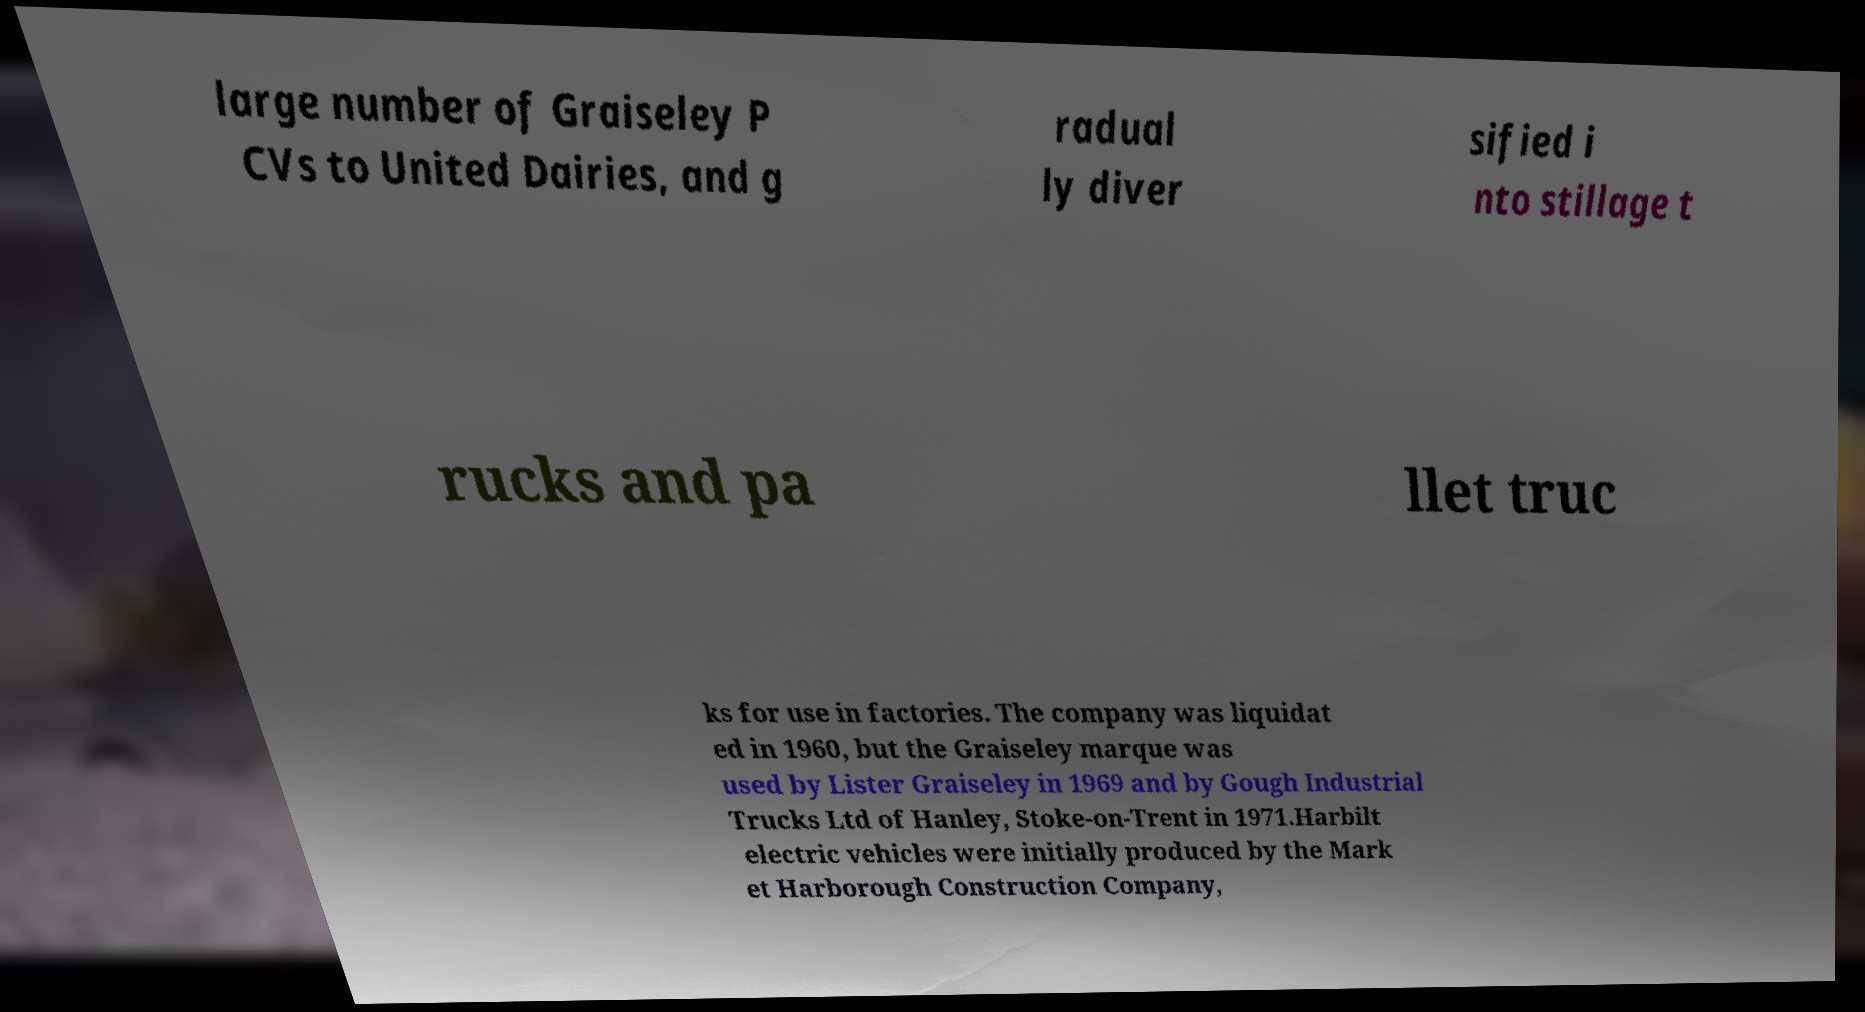Can you read and provide the text displayed in the image?This photo seems to have some interesting text. Can you extract and type it out for me? large number of Graiseley P CVs to United Dairies, and g radual ly diver sified i nto stillage t rucks and pa llet truc ks for use in factories. The company was liquidat ed in 1960, but the Graiseley marque was used by Lister Graiseley in 1969 and by Gough Industrial Trucks Ltd of Hanley, Stoke-on-Trent in 1971.Harbilt electric vehicles were initially produced by the Mark et Harborough Construction Company, 